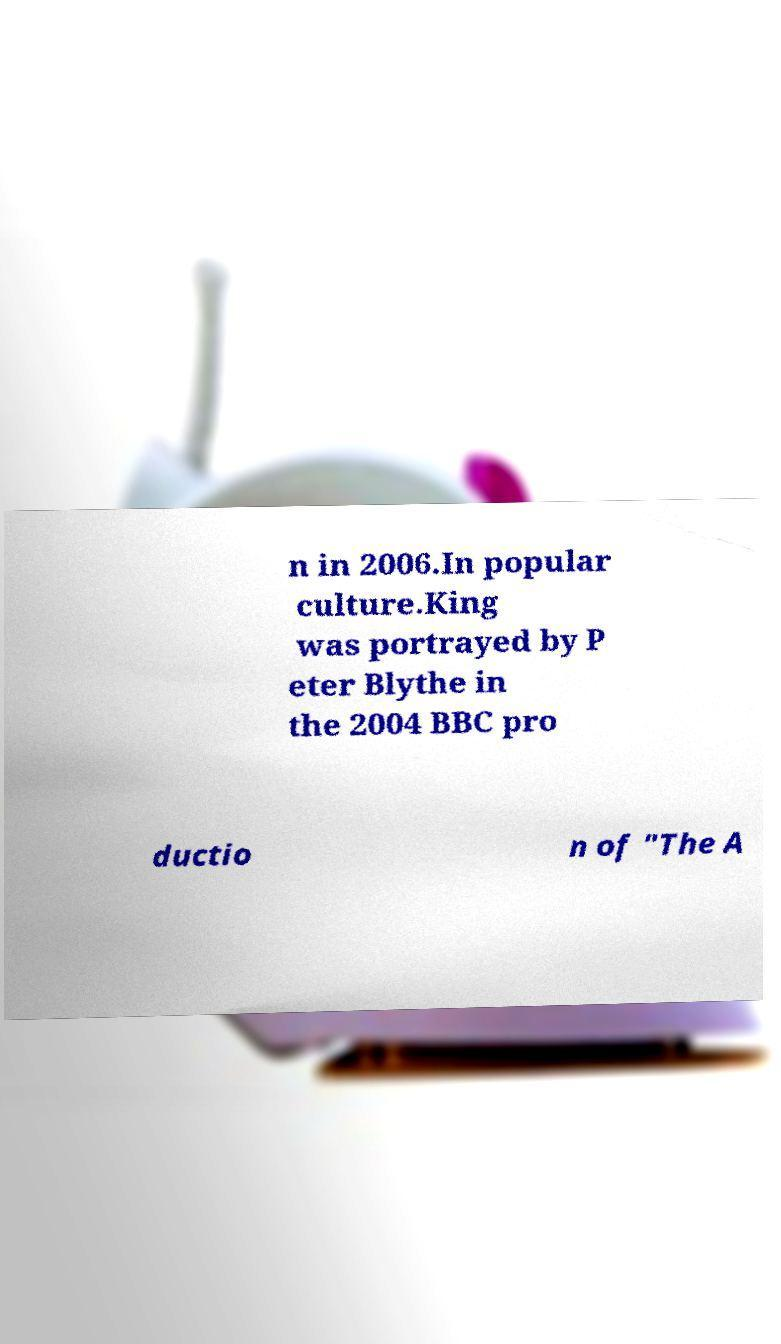I need the written content from this picture converted into text. Can you do that? n in 2006.In popular culture.King was portrayed by P eter Blythe in the 2004 BBC pro ductio n of "The A 